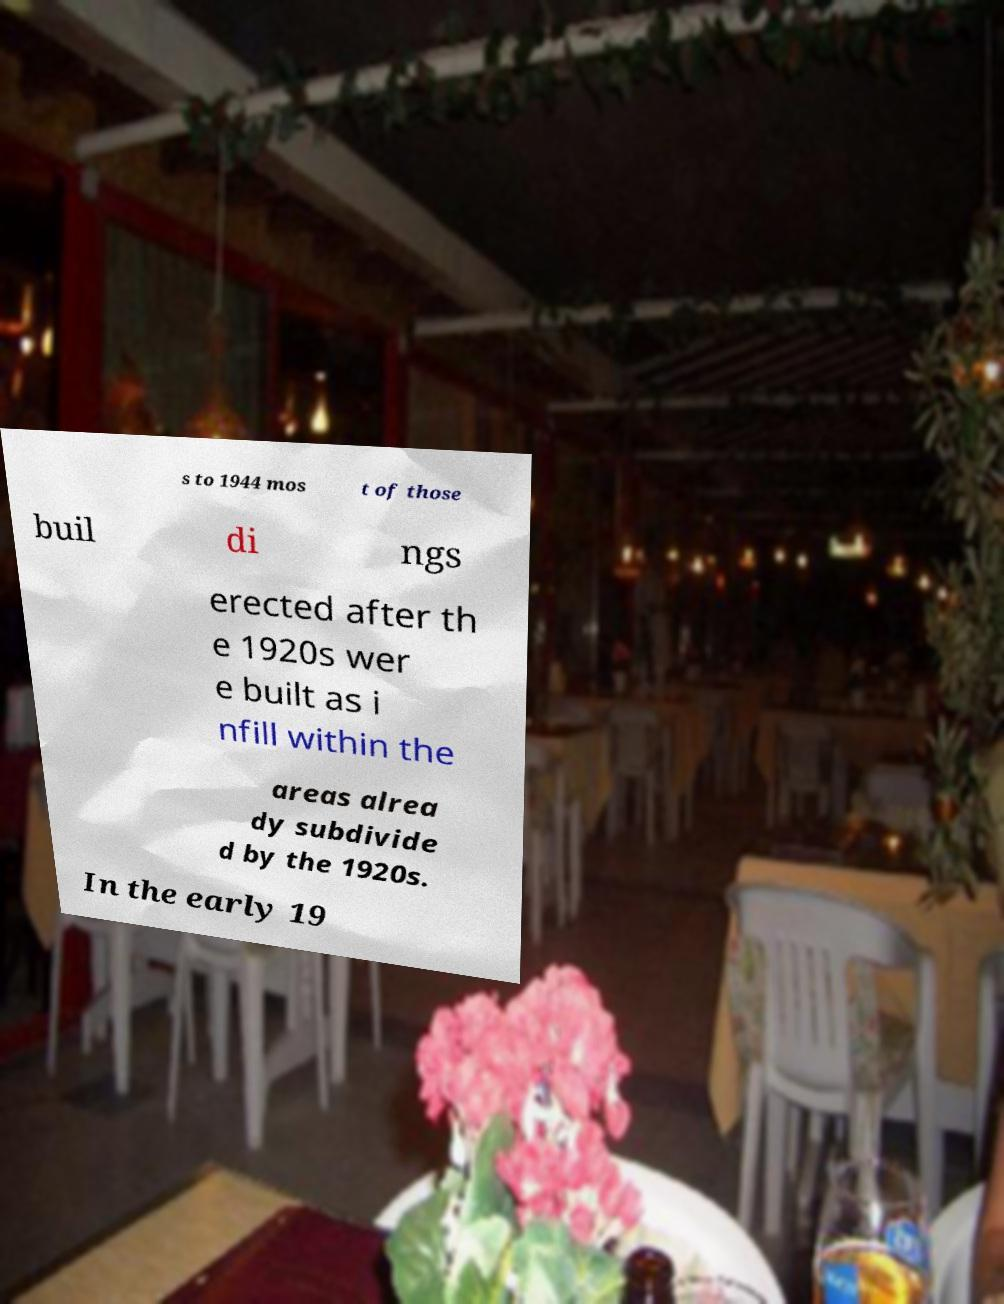I need the written content from this picture converted into text. Can you do that? s to 1944 mos t of those buil di ngs erected after th e 1920s wer e built as i nfill within the areas alrea dy subdivide d by the 1920s. In the early 19 